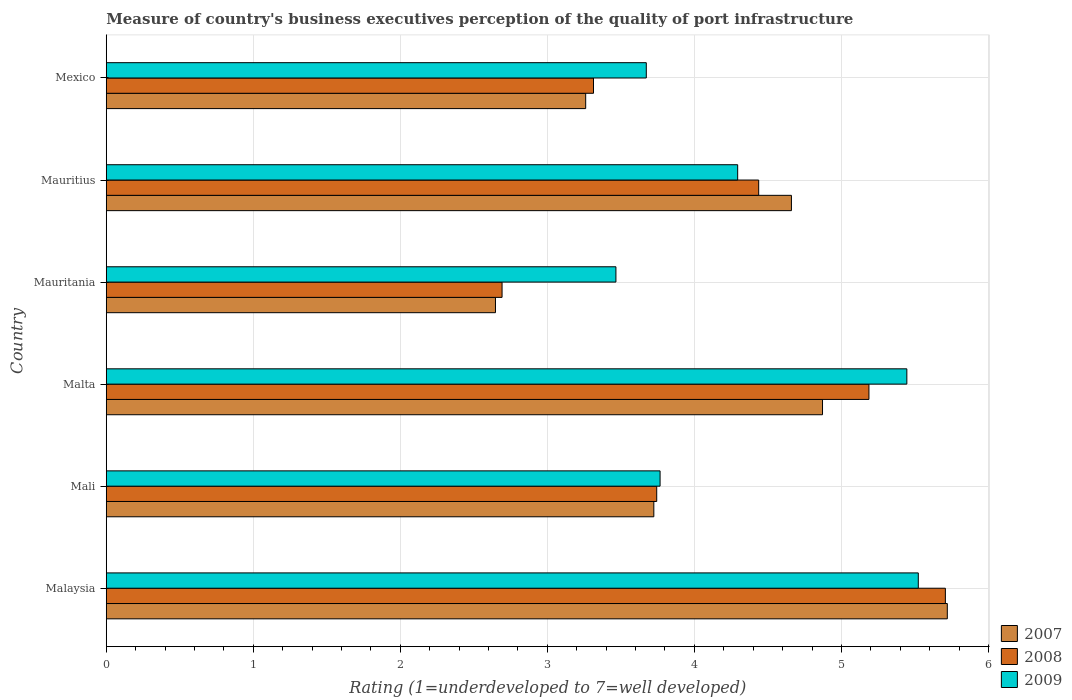How many different coloured bars are there?
Your answer should be compact. 3. How many groups of bars are there?
Offer a very short reply. 6. Are the number of bars per tick equal to the number of legend labels?
Provide a succinct answer. Yes. What is the label of the 2nd group of bars from the top?
Your answer should be compact. Mauritius. In how many cases, is the number of bars for a given country not equal to the number of legend labels?
Make the answer very short. 0. What is the ratings of the quality of port infrastructure in 2009 in Mali?
Offer a very short reply. 3.77. Across all countries, what is the maximum ratings of the quality of port infrastructure in 2008?
Provide a short and direct response. 5.71. Across all countries, what is the minimum ratings of the quality of port infrastructure in 2007?
Provide a short and direct response. 2.65. In which country was the ratings of the quality of port infrastructure in 2009 maximum?
Your answer should be very brief. Malaysia. In which country was the ratings of the quality of port infrastructure in 2007 minimum?
Make the answer very short. Mauritania. What is the total ratings of the quality of port infrastructure in 2007 in the graph?
Offer a terse response. 24.88. What is the difference between the ratings of the quality of port infrastructure in 2009 in Malaysia and that in Malta?
Offer a terse response. 0.08. What is the difference between the ratings of the quality of port infrastructure in 2009 in Mauritius and the ratings of the quality of port infrastructure in 2008 in Mauritania?
Give a very brief answer. 1.6. What is the average ratings of the quality of port infrastructure in 2009 per country?
Offer a terse response. 4.36. What is the difference between the ratings of the quality of port infrastructure in 2008 and ratings of the quality of port infrastructure in 2009 in Mali?
Offer a very short reply. -0.02. In how many countries, is the ratings of the quality of port infrastructure in 2007 greater than 5.8 ?
Provide a short and direct response. 0. What is the ratio of the ratings of the quality of port infrastructure in 2009 in Mali to that in Mauritania?
Provide a short and direct response. 1.09. Is the ratings of the quality of port infrastructure in 2008 in Malaysia less than that in Mali?
Make the answer very short. No. Is the difference between the ratings of the quality of port infrastructure in 2008 in Mali and Malta greater than the difference between the ratings of the quality of port infrastructure in 2009 in Mali and Malta?
Offer a terse response. Yes. What is the difference between the highest and the second highest ratings of the quality of port infrastructure in 2007?
Provide a short and direct response. 0.85. What is the difference between the highest and the lowest ratings of the quality of port infrastructure in 2007?
Give a very brief answer. 3.07. Is the sum of the ratings of the quality of port infrastructure in 2009 in Mali and Malta greater than the maximum ratings of the quality of port infrastructure in 2007 across all countries?
Your answer should be compact. Yes. What does the 2nd bar from the bottom in Mali represents?
Give a very brief answer. 2008. Is it the case that in every country, the sum of the ratings of the quality of port infrastructure in 2007 and ratings of the quality of port infrastructure in 2009 is greater than the ratings of the quality of port infrastructure in 2008?
Offer a very short reply. Yes. Are all the bars in the graph horizontal?
Provide a succinct answer. Yes. What is the difference between two consecutive major ticks on the X-axis?
Offer a very short reply. 1. Does the graph contain any zero values?
Your answer should be compact. No. How are the legend labels stacked?
Provide a succinct answer. Vertical. What is the title of the graph?
Ensure brevity in your answer.  Measure of country's business executives perception of the quality of port infrastructure. Does "2015" appear as one of the legend labels in the graph?
Offer a terse response. No. What is the label or title of the X-axis?
Your answer should be very brief. Rating (1=underdeveloped to 7=well developed). What is the label or title of the Y-axis?
Ensure brevity in your answer.  Country. What is the Rating (1=underdeveloped to 7=well developed) of 2007 in Malaysia?
Offer a very short reply. 5.72. What is the Rating (1=underdeveloped to 7=well developed) in 2008 in Malaysia?
Your answer should be compact. 5.71. What is the Rating (1=underdeveloped to 7=well developed) in 2009 in Malaysia?
Your answer should be compact. 5.52. What is the Rating (1=underdeveloped to 7=well developed) in 2007 in Mali?
Offer a terse response. 3.72. What is the Rating (1=underdeveloped to 7=well developed) in 2008 in Mali?
Provide a short and direct response. 3.74. What is the Rating (1=underdeveloped to 7=well developed) in 2009 in Mali?
Your answer should be very brief. 3.77. What is the Rating (1=underdeveloped to 7=well developed) in 2007 in Malta?
Your response must be concise. 4.87. What is the Rating (1=underdeveloped to 7=well developed) in 2008 in Malta?
Your answer should be very brief. 5.19. What is the Rating (1=underdeveloped to 7=well developed) of 2009 in Malta?
Keep it short and to the point. 5.44. What is the Rating (1=underdeveloped to 7=well developed) in 2007 in Mauritania?
Your answer should be compact. 2.65. What is the Rating (1=underdeveloped to 7=well developed) in 2008 in Mauritania?
Make the answer very short. 2.69. What is the Rating (1=underdeveloped to 7=well developed) in 2009 in Mauritania?
Your response must be concise. 3.47. What is the Rating (1=underdeveloped to 7=well developed) in 2007 in Mauritius?
Your response must be concise. 4.66. What is the Rating (1=underdeveloped to 7=well developed) of 2008 in Mauritius?
Offer a terse response. 4.44. What is the Rating (1=underdeveloped to 7=well developed) in 2009 in Mauritius?
Your answer should be compact. 4.29. What is the Rating (1=underdeveloped to 7=well developed) of 2007 in Mexico?
Make the answer very short. 3.26. What is the Rating (1=underdeveloped to 7=well developed) in 2008 in Mexico?
Ensure brevity in your answer.  3.31. What is the Rating (1=underdeveloped to 7=well developed) of 2009 in Mexico?
Your response must be concise. 3.67. Across all countries, what is the maximum Rating (1=underdeveloped to 7=well developed) of 2007?
Your answer should be very brief. 5.72. Across all countries, what is the maximum Rating (1=underdeveloped to 7=well developed) of 2008?
Offer a very short reply. 5.71. Across all countries, what is the maximum Rating (1=underdeveloped to 7=well developed) of 2009?
Offer a very short reply. 5.52. Across all countries, what is the minimum Rating (1=underdeveloped to 7=well developed) of 2007?
Give a very brief answer. 2.65. Across all countries, what is the minimum Rating (1=underdeveloped to 7=well developed) of 2008?
Provide a succinct answer. 2.69. Across all countries, what is the minimum Rating (1=underdeveloped to 7=well developed) of 2009?
Provide a short and direct response. 3.47. What is the total Rating (1=underdeveloped to 7=well developed) in 2007 in the graph?
Offer a very short reply. 24.88. What is the total Rating (1=underdeveloped to 7=well developed) of 2008 in the graph?
Ensure brevity in your answer.  25.08. What is the total Rating (1=underdeveloped to 7=well developed) in 2009 in the graph?
Ensure brevity in your answer.  26.17. What is the difference between the Rating (1=underdeveloped to 7=well developed) of 2007 in Malaysia and that in Mali?
Keep it short and to the point. 2. What is the difference between the Rating (1=underdeveloped to 7=well developed) of 2008 in Malaysia and that in Mali?
Your answer should be very brief. 1.96. What is the difference between the Rating (1=underdeveloped to 7=well developed) in 2009 in Malaysia and that in Mali?
Provide a succinct answer. 1.76. What is the difference between the Rating (1=underdeveloped to 7=well developed) of 2007 in Malaysia and that in Malta?
Give a very brief answer. 0.85. What is the difference between the Rating (1=underdeveloped to 7=well developed) of 2008 in Malaysia and that in Malta?
Your response must be concise. 0.52. What is the difference between the Rating (1=underdeveloped to 7=well developed) in 2009 in Malaysia and that in Malta?
Your answer should be very brief. 0.08. What is the difference between the Rating (1=underdeveloped to 7=well developed) in 2007 in Malaysia and that in Mauritania?
Give a very brief answer. 3.07. What is the difference between the Rating (1=underdeveloped to 7=well developed) of 2008 in Malaysia and that in Mauritania?
Your response must be concise. 3.02. What is the difference between the Rating (1=underdeveloped to 7=well developed) in 2009 in Malaysia and that in Mauritania?
Your answer should be compact. 2.06. What is the difference between the Rating (1=underdeveloped to 7=well developed) in 2007 in Malaysia and that in Mauritius?
Your answer should be very brief. 1.06. What is the difference between the Rating (1=underdeveloped to 7=well developed) in 2008 in Malaysia and that in Mauritius?
Ensure brevity in your answer.  1.27. What is the difference between the Rating (1=underdeveloped to 7=well developed) in 2009 in Malaysia and that in Mauritius?
Give a very brief answer. 1.23. What is the difference between the Rating (1=underdeveloped to 7=well developed) of 2007 in Malaysia and that in Mexico?
Make the answer very short. 2.46. What is the difference between the Rating (1=underdeveloped to 7=well developed) of 2008 in Malaysia and that in Mexico?
Your response must be concise. 2.39. What is the difference between the Rating (1=underdeveloped to 7=well developed) in 2009 in Malaysia and that in Mexico?
Your response must be concise. 1.85. What is the difference between the Rating (1=underdeveloped to 7=well developed) in 2007 in Mali and that in Malta?
Give a very brief answer. -1.15. What is the difference between the Rating (1=underdeveloped to 7=well developed) of 2008 in Mali and that in Malta?
Your response must be concise. -1.44. What is the difference between the Rating (1=underdeveloped to 7=well developed) of 2009 in Mali and that in Malta?
Make the answer very short. -1.68. What is the difference between the Rating (1=underdeveloped to 7=well developed) of 2007 in Mali and that in Mauritania?
Ensure brevity in your answer.  1.08. What is the difference between the Rating (1=underdeveloped to 7=well developed) of 2008 in Mali and that in Mauritania?
Your answer should be compact. 1.05. What is the difference between the Rating (1=underdeveloped to 7=well developed) of 2009 in Mali and that in Mauritania?
Give a very brief answer. 0.3. What is the difference between the Rating (1=underdeveloped to 7=well developed) of 2007 in Mali and that in Mauritius?
Offer a very short reply. -0.94. What is the difference between the Rating (1=underdeveloped to 7=well developed) of 2008 in Mali and that in Mauritius?
Offer a very short reply. -0.69. What is the difference between the Rating (1=underdeveloped to 7=well developed) in 2009 in Mali and that in Mauritius?
Provide a short and direct response. -0.53. What is the difference between the Rating (1=underdeveloped to 7=well developed) in 2007 in Mali and that in Mexico?
Give a very brief answer. 0.46. What is the difference between the Rating (1=underdeveloped to 7=well developed) of 2008 in Mali and that in Mexico?
Your answer should be very brief. 0.43. What is the difference between the Rating (1=underdeveloped to 7=well developed) of 2009 in Mali and that in Mexico?
Your response must be concise. 0.09. What is the difference between the Rating (1=underdeveloped to 7=well developed) of 2007 in Malta and that in Mauritania?
Your answer should be compact. 2.22. What is the difference between the Rating (1=underdeveloped to 7=well developed) of 2008 in Malta and that in Mauritania?
Make the answer very short. 2.5. What is the difference between the Rating (1=underdeveloped to 7=well developed) of 2009 in Malta and that in Mauritania?
Make the answer very short. 1.98. What is the difference between the Rating (1=underdeveloped to 7=well developed) in 2007 in Malta and that in Mauritius?
Your response must be concise. 0.21. What is the difference between the Rating (1=underdeveloped to 7=well developed) of 2008 in Malta and that in Mauritius?
Your answer should be very brief. 0.75. What is the difference between the Rating (1=underdeveloped to 7=well developed) in 2009 in Malta and that in Mauritius?
Give a very brief answer. 1.15. What is the difference between the Rating (1=underdeveloped to 7=well developed) in 2007 in Malta and that in Mexico?
Your answer should be very brief. 1.61. What is the difference between the Rating (1=underdeveloped to 7=well developed) of 2008 in Malta and that in Mexico?
Give a very brief answer. 1.87. What is the difference between the Rating (1=underdeveloped to 7=well developed) of 2009 in Malta and that in Mexico?
Keep it short and to the point. 1.77. What is the difference between the Rating (1=underdeveloped to 7=well developed) in 2007 in Mauritania and that in Mauritius?
Provide a short and direct response. -2.01. What is the difference between the Rating (1=underdeveloped to 7=well developed) in 2008 in Mauritania and that in Mauritius?
Offer a very short reply. -1.75. What is the difference between the Rating (1=underdeveloped to 7=well developed) in 2009 in Mauritania and that in Mauritius?
Make the answer very short. -0.83. What is the difference between the Rating (1=underdeveloped to 7=well developed) in 2007 in Mauritania and that in Mexico?
Keep it short and to the point. -0.61. What is the difference between the Rating (1=underdeveloped to 7=well developed) in 2008 in Mauritania and that in Mexico?
Keep it short and to the point. -0.62. What is the difference between the Rating (1=underdeveloped to 7=well developed) of 2009 in Mauritania and that in Mexico?
Your answer should be compact. -0.21. What is the difference between the Rating (1=underdeveloped to 7=well developed) in 2007 in Mauritius and that in Mexico?
Ensure brevity in your answer.  1.4. What is the difference between the Rating (1=underdeveloped to 7=well developed) of 2008 in Mauritius and that in Mexico?
Give a very brief answer. 1.12. What is the difference between the Rating (1=underdeveloped to 7=well developed) of 2009 in Mauritius and that in Mexico?
Provide a short and direct response. 0.62. What is the difference between the Rating (1=underdeveloped to 7=well developed) of 2007 in Malaysia and the Rating (1=underdeveloped to 7=well developed) of 2008 in Mali?
Your answer should be compact. 1.98. What is the difference between the Rating (1=underdeveloped to 7=well developed) of 2007 in Malaysia and the Rating (1=underdeveloped to 7=well developed) of 2009 in Mali?
Keep it short and to the point. 1.95. What is the difference between the Rating (1=underdeveloped to 7=well developed) of 2008 in Malaysia and the Rating (1=underdeveloped to 7=well developed) of 2009 in Mali?
Offer a very short reply. 1.94. What is the difference between the Rating (1=underdeveloped to 7=well developed) in 2007 in Malaysia and the Rating (1=underdeveloped to 7=well developed) in 2008 in Malta?
Give a very brief answer. 0.53. What is the difference between the Rating (1=underdeveloped to 7=well developed) in 2007 in Malaysia and the Rating (1=underdeveloped to 7=well developed) in 2009 in Malta?
Make the answer very short. 0.28. What is the difference between the Rating (1=underdeveloped to 7=well developed) of 2008 in Malaysia and the Rating (1=underdeveloped to 7=well developed) of 2009 in Malta?
Offer a very short reply. 0.26. What is the difference between the Rating (1=underdeveloped to 7=well developed) of 2007 in Malaysia and the Rating (1=underdeveloped to 7=well developed) of 2008 in Mauritania?
Ensure brevity in your answer.  3.03. What is the difference between the Rating (1=underdeveloped to 7=well developed) in 2007 in Malaysia and the Rating (1=underdeveloped to 7=well developed) in 2009 in Mauritania?
Your answer should be compact. 2.25. What is the difference between the Rating (1=underdeveloped to 7=well developed) of 2008 in Malaysia and the Rating (1=underdeveloped to 7=well developed) of 2009 in Mauritania?
Provide a short and direct response. 2.24. What is the difference between the Rating (1=underdeveloped to 7=well developed) of 2007 in Malaysia and the Rating (1=underdeveloped to 7=well developed) of 2008 in Mauritius?
Offer a very short reply. 1.28. What is the difference between the Rating (1=underdeveloped to 7=well developed) in 2007 in Malaysia and the Rating (1=underdeveloped to 7=well developed) in 2009 in Mauritius?
Give a very brief answer. 1.43. What is the difference between the Rating (1=underdeveloped to 7=well developed) in 2008 in Malaysia and the Rating (1=underdeveloped to 7=well developed) in 2009 in Mauritius?
Your response must be concise. 1.41. What is the difference between the Rating (1=underdeveloped to 7=well developed) of 2007 in Malaysia and the Rating (1=underdeveloped to 7=well developed) of 2008 in Mexico?
Ensure brevity in your answer.  2.41. What is the difference between the Rating (1=underdeveloped to 7=well developed) in 2007 in Malaysia and the Rating (1=underdeveloped to 7=well developed) in 2009 in Mexico?
Your answer should be compact. 2.05. What is the difference between the Rating (1=underdeveloped to 7=well developed) in 2008 in Malaysia and the Rating (1=underdeveloped to 7=well developed) in 2009 in Mexico?
Your answer should be very brief. 2.03. What is the difference between the Rating (1=underdeveloped to 7=well developed) in 2007 in Mali and the Rating (1=underdeveloped to 7=well developed) in 2008 in Malta?
Your answer should be very brief. -1.46. What is the difference between the Rating (1=underdeveloped to 7=well developed) in 2007 in Mali and the Rating (1=underdeveloped to 7=well developed) in 2009 in Malta?
Give a very brief answer. -1.72. What is the difference between the Rating (1=underdeveloped to 7=well developed) in 2008 in Mali and the Rating (1=underdeveloped to 7=well developed) in 2009 in Malta?
Ensure brevity in your answer.  -1.7. What is the difference between the Rating (1=underdeveloped to 7=well developed) in 2007 in Mali and the Rating (1=underdeveloped to 7=well developed) in 2008 in Mauritania?
Provide a short and direct response. 1.03. What is the difference between the Rating (1=underdeveloped to 7=well developed) of 2007 in Mali and the Rating (1=underdeveloped to 7=well developed) of 2009 in Mauritania?
Your response must be concise. 0.26. What is the difference between the Rating (1=underdeveloped to 7=well developed) in 2008 in Mali and the Rating (1=underdeveloped to 7=well developed) in 2009 in Mauritania?
Your answer should be compact. 0.28. What is the difference between the Rating (1=underdeveloped to 7=well developed) of 2007 in Mali and the Rating (1=underdeveloped to 7=well developed) of 2008 in Mauritius?
Your answer should be compact. -0.71. What is the difference between the Rating (1=underdeveloped to 7=well developed) of 2007 in Mali and the Rating (1=underdeveloped to 7=well developed) of 2009 in Mauritius?
Your answer should be very brief. -0.57. What is the difference between the Rating (1=underdeveloped to 7=well developed) of 2008 in Mali and the Rating (1=underdeveloped to 7=well developed) of 2009 in Mauritius?
Ensure brevity in your answer.  -0.55. What is the difference between the Rating (1=underdeveloped to 7=well developed) in 2007 in Mali and the Rating (1=underdeveloped to 7=well developed) in 2008 in Mexico?
Give a very brief answer. 0.41. What is the difference between the Rating (1=underdeveloped to 7=well developed) of 2007 in Mali and the Rating (1=underdeveloped to 7=well developed) of 2009 in Mexico?
Offer a very short reply. 0.05. What is the difference between the Rating (1=underdeveloped to 7=well developed) in 2008 in Mali and the Rating (1=underdeveloped to 7=well developed) in 2009 in Mexico?
Provide a short and direct response. 0.07. What is the difference between the Rating (1=underdeveloped to 7=well developed) of 2007 in Malta and the Rating (1=underdeveloped to 7=well developed) of 2008 in Mauritania?
Offer a terse response. 2.18. What is the difference between the Rating (1=underdeveloped to 7=well developed) of 2007 in Malta and the Rating (1=underdeveloped to 7=well developed) of 2009 in Mauritania?
Your answer should be compact. 1.41. What is the difference between the Rating (1=underdeveloped to 7=well developed) in 2008 in Malta and the Rating (1=underdeveloped to 7=well developed) in 2009 in Mauritania?
Give a very brief answer. 1.72. What is the difference between the Rating (1=underdeveloped to 7=well developed) of 2007 in Malta and the Rating (1=underdeveloped to 7=well developed) of 2008 in Mauritius?
Provide a short and direct response. 0.43. What is the difference between the Rating (1=underdeveloped to 7=well developed) in 2007 in Malta and the Rating (1=underdeveloped to 7=well developed) in 2009 in Mauritius?
Ensure brevity in your answer.  0.58. What is the difference between the Rating (1=underdeveloped to 7=well developed) in 2008 in Malta and the Rating (1=underdeveloped to 7=well developed) in 2009 in Mauritius?
Provide a succinct answer. 0.89. What is the difference between the Rating (1=underdeveloped to 7=well developed) of 2007 in Malta and the Rating (1=underdeveloped to 7=well developed) of 2008 in Mexico?
Ensure brevity in your answer.  1.56. What is the difference between the Rating (1=underdeveloped to 7=well developed) of 2007 in Malta and the Rating (1=underdeveloped to 7=well developed) of 2009 in Mexico?
Your answer should be compact. 1.2. What is the difference between the Rating (1=underdeveloped to 7=well developed) in 2008 in Malta and the Rating (1=underdeveloped to 7=well developed) in 2009 in Mexico?
Provide a succinct answer. 1.51. What is the difference between the Rating (1=underdeveloped to 7=well developed) of 2007 in Mauritania and the Rating (1=underdeveloped to 7=well developed) of 2008 in Mauritius?
Your answer should be compact. -1.79. What is the difference between the Rating (1=underdeveloped to 7=well developed) of 2007 in Mauritania and the Rating (1=underdeveloped to 7=well developed) of 2009 in Mauritius?
Your answer should be very brief. -1.65. What is the difference between the Rating (1=underdeveloped to 7=well developed) in 2008 in Mauritania and the Rating (1=underdeveloped to 7=well developed) in 2009 in Mauritius?
Ensure brevity in your answer.  -1.6. What is the difference between the Rating (1=underdeveloped to 7=well developed) in 2007 in Mauritania and the Rating (1=underdeveloped to 7=well developed) in 2008 in Mexico?
Offer a very short reply. -0.67. What is the difference between the Rating (1=underdeveloped to 7=well developed) in 2007 in Mauritania and the Rating (1=underdeveloped to 7=well developed) in 2009 in Mexico?
Give a very brief answer. -1.03. What is the difference between the Rating (1=underdeveloped to 7=well developed) in 2008 in Mauritania and the Rating (1=underdeveloped to 7=well developed) in 2009 in Mexico?
Ensure brevity in your answer.  -0.98. What is the difference between the Rating (1=underdeveloped to 7=well developed) in 2007 in Mauritius and the Rating (1=underdeveloped to 7=well developed) in 2008 in Mexico?
Your answer should be compact. 1.35. What is the difference between the Rating (1=underdeveloped to 7=well developed) of 2008 in Mauritius and the Rating (1=underdeveloped to 7=well developed) of 2009 in Mexico?
Offer a terse response. 0.76. What is the average Rating (1=underdeveloped to 7=well developed) of 2007 per country?
Your answer should be compact. 4.15. What is the average Rating (1=underdeveloped to 7=well developed) in 2008 per country?
Your response must be concise. 4.18. What is the average Rating (1=underdeveloped to 7=well developed) of 2009 per country?
Give a very brief answer. 4.36. What is the difference between the Rating (1=underdeveloped to 7=well developed) of 2007 and Rating (1=underdeveloped to 7=well developed) of 2008 in Malaysia?
Make the answer very short. 0.01. What is the difference between the Rating (1=underdeveloped to 7=well developed) of 2007 and Rating (1=underdeveloped to 7=well developed) of 2009 in Malaysia?
Your response must be concise. 0.2. What is the difference between the Rating (1=underdeveloped to 7=well developed) of 2008 and Rating (1=underdeveloped to 7=well developed) of 2009 in Malaysia?
Your answer should be compact. 0.18. What is the difference between the Rating (1=underdeveloped to 7=well developed) of 2007 and Rating (1=underdeveloped to 7=well developed) of 2008 in Mali?
Offer a terse response. -0.02. What is the difference between the Rating (1=underdeveloped to 7=well developed) in 2007 and Rating (1=underdeveloped to 7=well developed) in 2009 in Mali?
Ensure brevity in your answer.  -0.04. What is the difference between the Rating (1=underdeveloped to 7=well developed) of 2008 and Rating (1=underdeveloped to 7=well developed) of 2009 in Mali?
Your response must be concise. -0.02. What is the difference between the Rating (1=underdeveloped to 7=well developed) of 2007 and Rating (1=underdeveloped to 7=well developed) of 2008 in Malta?
Your answer should be very brief. -0.32. What is the difference between the Rating (1=underdeveloped to 7=well developed) of 2007 and Rating (1=underdeveloped to 7=well developed) of 2009 in Malta?
Provide a short and direct response. -0.57. What is the difference between the Rating (1=underdeveloped to 7=well developed) of 2008 and Rating (1=underdeveloped to 7=well developed) of 2009 in Malta?
Your answer should be very brief. -0.26. What is the difference between the Rating (1=underdeveloped to 7=well developed) in 2007 and Rating (1=underdeveloped to 7=well developed) in 2008 in Mauritania?
Offer a terse response. -0.04. What is the difference between the Rating (1=underdeveloped to 7=well developed) of 2007 and Rating (1=underdeveloped to 7=well developed) of 2009 in Mauritania?
Offer a very short reply. -0.82. What is the difference between the Rating (1=underdeveloped to 7=well developed) in 2008 and Rating (1=underdeveloped to 7=well developed) in 2009 in Mauritania?
Provide a succinct answer. -0.77. What is the difference between the Rating (1=underdeveloped to 7=well developed) of 2007 and Rating (1=underdeveloped to 7=well developed) of 2008 in Mauritius?
Make the answer very short. 0.22. What is the difference between the Rating (1=underdeveloped to 7=well developed) in 2007 and Rating (1=underdeveloped to 7=well developed) in 2009 in Mauritius?
Your answer should be compact. 0.37. What is the difference between the Rating (1=underdeveloped to 7=well developed) of 2008 and Rating (1=underdeveloped to 7=well developed) of 2009 in Mauritius?
Give a very brief answer. 0.14. What is the difference between the Rating (1=underdeveloped to 7=well developed) of 2007 and Rating (1=underdeveloped to 7=well developed) of 2008 in Mexico?
Offer a terse response. -0.05. What is the difference between the Rating (1=underdeveloped to 7=well developed) of 2007 and Rating (1=underdeveloped to 7=well developed) of 2009 in Mexico?
Your answer should be very brief. -0.41. What is the difference between the Rating (1=underdeveloped to 7=well developed) of 2008 and Rating (1=underdeveloped to 7=well developed) of 2009 in Mexico?
Ensure brevity in your answer.  -0.36. What is the ratio of the Rating (1=underdeveloped to 7=well developed) in 2007 in Malaysia to that in Mali?
Keep it short and to the point. 1.54. What is the ratio of the Rating (1=underdeveloped to 7=well developed) in 2008 in Malaysia to that in Mali?
Offer a very short reply. 1.52. What is the ratio of the Rating (1=underdeveloped to 7=well developed) of 2009 in Malaysia to that in Mali?
Your answer should be compact. 1.47. What is the ratio of the Rating (1=underdeveloped to 7=well developed) in 2007 in Malaysia to that in Malta?
Ensure brevity in your answer.  1.17. What is the ratio of the Rating (1=underdeveloped to 7=well developed) of 2008 in Malaysia to that in Malta?
Offer a terse response. 1.1. What is the ratio of the Rating (1=underdeveloped to 7=well developed) in 2009 in Malaysia to that in Malta?
Ensure brevity in your answer.  1.01. What is the ratio of the Rating (1=underdeveloped to 7=well developed) in 2007 in Malaysia to that in Mauritania?
Ensure brevity in your answer.  2.16. What is the ratio of the Rating (1=underdeveloped to 7=well developed) in 2008 in Malaysia to that in Mauritania?
Make the answer very short. 2.12. What is the ratio of the Rating (1=underdeveloped to 7=well developed) in 2009 in Malaysia to that in Mauritania?
Make the answer very short. 1.59. What is the ratio of the Rating (1=underdeveloped to 7=well developed) in 2007 in Malaysia to that in Mauritius?
Offer a terse response. 1.23. What is the ratio of the Rating (1=underdeveloped to 7=well developed) of 2008 in Malaysia to that in Mauritius?
Provide a succinct answer. 1.29. What is the ratio of the Rating (1=underdeveloped to 7=well developed) in 2009 in Malaysia to that in Mauritius?
Make the answer very short. 1.29. What is the ratio of the Rating (1=underdeveloped to 7=well developed) in 2007 in Malaysia to that in Mexico?
Your response must be concise. 1.75. What is the ratio of the Rating (1=underdeveloped to 7=well developed) in 2008 in Malaysia to that in Mexico?
Provide a short and direct response. 1.72. What is the ratio of the Rating (1=underdeveloped to 7=well developed) in 2009 in Malaysia to that in Mexico?
Offer a very short reply. 1.5. What is the ratio of the Rating (1=underdeveloped to 7=well developed) of 2007 in Mali to that in Malta?
Ensure brevity in your answer.  0.76. What is the ratio of the Rating (1=underdeveloped to 7=well developed) of 2008 in Mali to that in Malta?
Give a very brief answer. 0.72. What is the ratio of the Rating (1=underdeveloped to 7=well developed) of 2009 in Mali to that in Malta?
Make the answer very short. 0.69. What is the ratio of the Rating (1=underdeveloped to 7=well developed) of 2007 in Mali to that in Mauritania?
Give a very brief answer. 1.41. What is the ratio of the Rating (1=underdeveloped to 7=well developed) in 2008 in Mali to that in Mauritania?
Offer a very short reply. 1.39. What is the ratio of the Rating (1=underdeveloped to 7=well developed) of 2009 in Mali to that in Mauritania?
Keep it short and to the point. 1.09. What is the ratio of the Rating (1=underdeveloped to 7=well developed) of 2007 in Mali to that in Mauritius?
Your answer should be very brief. 0.8. What is the ratio of the Rating (1=underdeveloped to 7=well developed) in 2008 in Mali to that in Mauritius?
Ensure brevity in your answer.  0.84. What is the ratio of the Rating (1=underdeveloped to 7=well developed) of 2009 in Mali to that in Mauritius?
Ensure brevity in your answer.  0.88. What is the ratio of the Rating (1=underdeveloped to 7=well developed) of 2007 in Mali to that in Mexico?
Make the answer very short. 1.14. What is the ratio of the Rating (1=underdeveloped to 7=well developed) in 2008 in Mali to that in Mexico?
Provide a short and direct response. 1.13. What is the ratio of the Rating (1=underdeveloped to 7=well developed) of 2009 in Mali to that in Mexico?
Offer a very short reply. 1.03. What is the ratio of the Rating (1=underdeveloped to 7=well developed) of 2007 in Malta to that in Mauritania?
Give a very brief answer. 1.84. What is the ratio of the Rating (1=underdeveloped to 7=well developed) in 2008 in Malta to that in Mauritania?
Provide a succinct answer. 1.93. What is the ratio of the Rating (1=underdeveloped to 7=well developed) of 2009 in Malta to that in Mauritania?
Your response must be concise. 1.57. What is the ratio of the Rating (1=underdeveloped to 7=well developed) of 2007 in Malta to that in Mauritius?
Keep it short and to the point. 1.05. What is the ratio of the Rating (1=underdeveloped to 7=well developed) of 2008 in Malta to that in Mauritius?
Make the answer very short. 1.17. What is the ratio of the Rating (1=underdeveloped to 7=well developed) in 2009 in Malta to that in Mauritius?
Give a very brief answer. 1.27. What is the ratio of the Rating (1=underdeveloped to 7=well developed) in 2007 in Malta to that in Mexico?
Keep it short and to the point. 1.49. What is the ratio of the Rating (1=underdeveloped to 7=well developed) in 2008 in Malta to that in Mexico?
Make the answer very short. 1.57. What is the ratio of the Rating (1=underdeveloped to 7=well developed) of 2009 in Malta to that in Mexico?
Your answer should be compact. 1.48. What is the ratio of the Rating (1=underdeveloped to 7=well developed) in 2007 in Mauritania to that in Mauritius?
Offer a very short reply. 0.57. What is the ratio of the Rating (1=underdeveloped to 7=well developed) in 2008 in Mauritania to that in Mauritius?
Your response must be concise. 0.61. What is the ratio of the Rating (1=underdeveloped to 7=well developed) in 2009 in Mauritania to that in Mauritius?
Your response must be concise. 0.81. What is the ratio of the Rating (1=underdeveloped to 7=well developed) in 2007 in Mauritania to that in Mexico?
Make the answer very short. 0.81. What is the ratio of the Rating (1=underdeveloped to 7=well developed) of 2008 in Mauritania to that in Mexico?
Provide a succinct answer. 0.81. What is the ratio of the Rating (1=underdeveloped to 7=well developed) of 2009 in Mauritania to that in Mexico?
Offer a terse response. 0.94. What is the ratio of the Rating (1=underdeveloped to 7=well developed) of 2007 in Mauritius to that in Mexico?
Provide a succinct answer. 1.43. What is the ratio of the Rating (1=underdeveloped to 7=well developed) of 2008 in Mauritius to that in Mexico?
Offer a terse response. 1.34. What is the ratio of the Rating (1=underdeveloped to 7=well developed) in 2009 in Mauritius to that in Mexico?
Your answer should be compact. 1.17. What is the difference between the highest and the second highest Rating (1=underdeveloped to 7=well developed) in 2007?
Your answer should be very brief. 0.85. What is the difference between the highest and the second highest Rating (1=underdeveloped to 7=well developed) in 2008?
Your answer should be very brief. 0.52. What is the difference between the highest and the second highest Rating (1=underdeveloped to 7=well developed) of 2009?
Your answer should be very brief. 0.08. What is the difference between the highest and the lowest Rating (1=underdeveloped to 7=well developed) of 2007?
Give a very brief answer. 3.07. What is the difference between the highest and the lowest Rating (1=underdeveloped to 7=well developed) in 2008?
Your answer should be compact. 3.02. What is the difference between the highest and the lowest Rating (1=underdeveloped to 7=well developed) of 2009?
Provide a short and direct response. 2.06. 